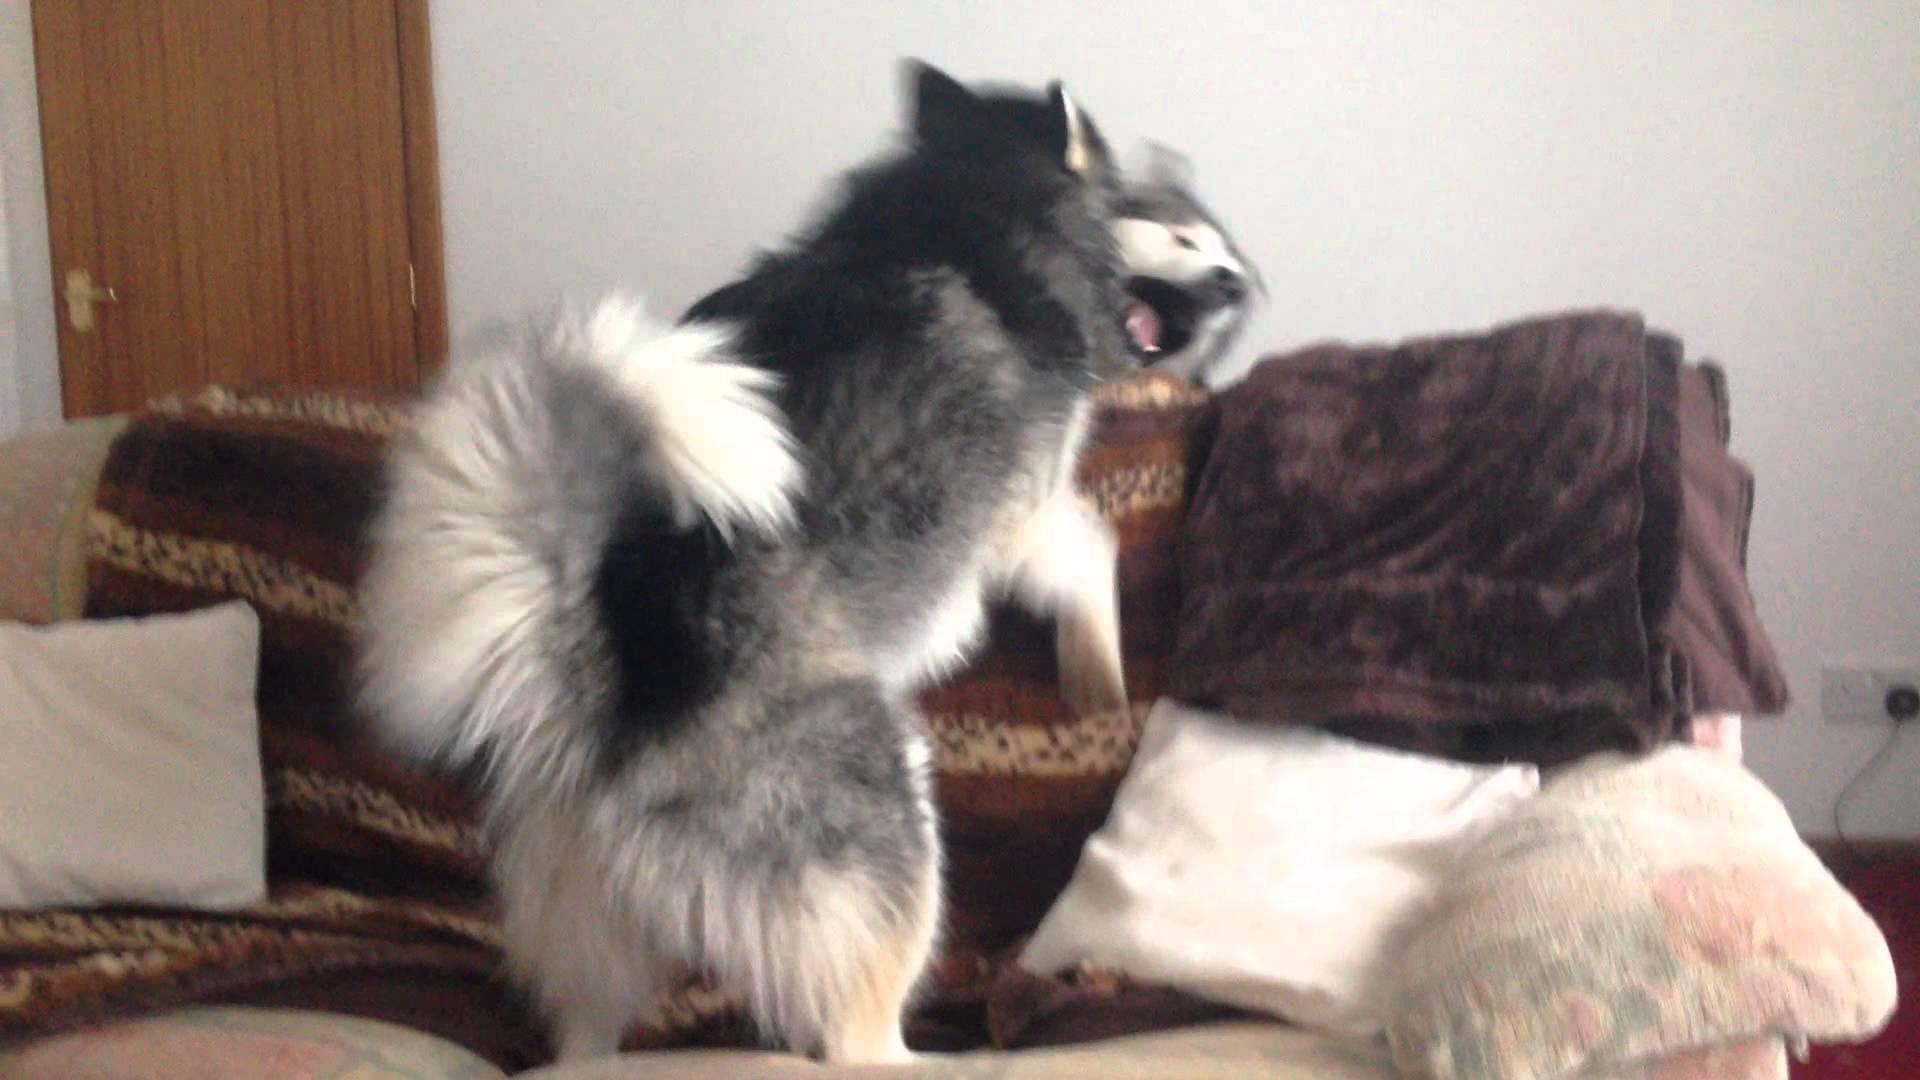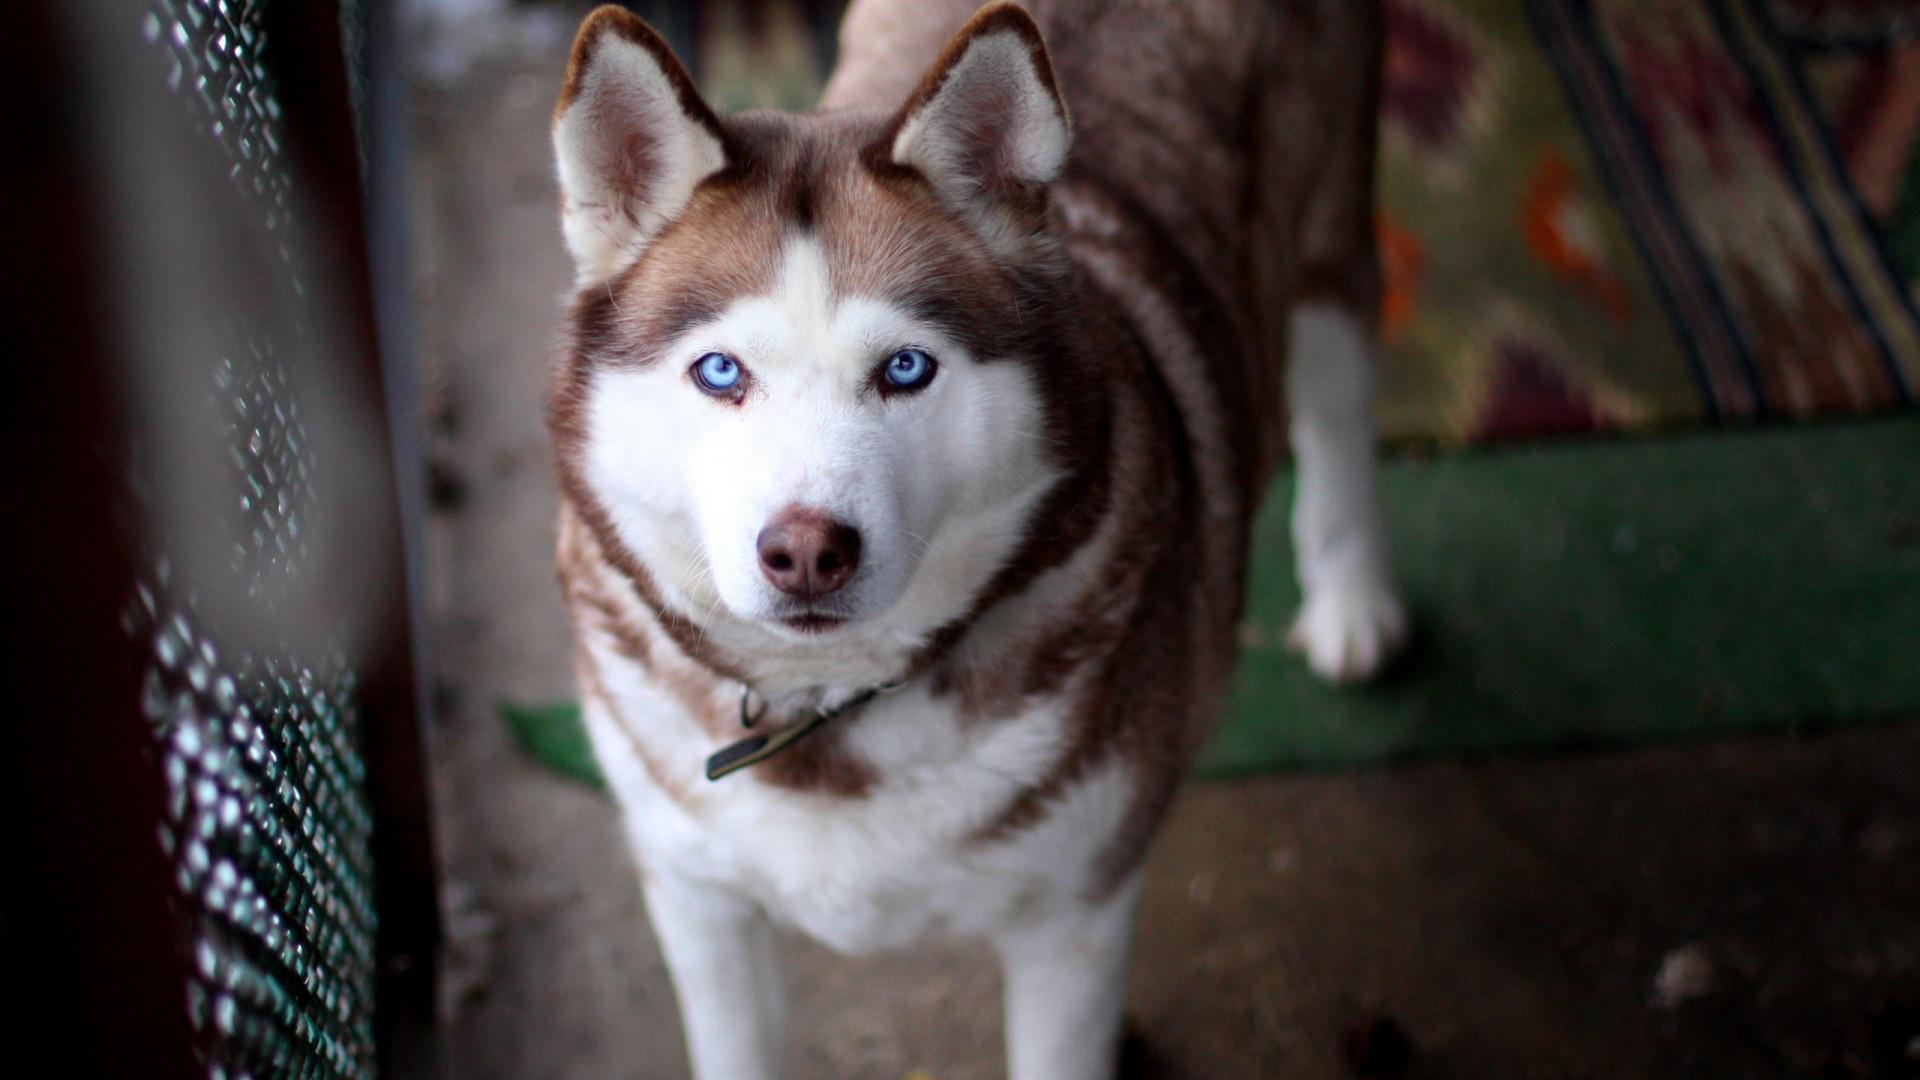The first image is the image on the left, the second image is the image on the right. Considering the images on both sides, is "Each image contains just one dog, all dogs are black-and-white husky types, and the dog on the right is reclining with extended front paws." valid? Answer yes or no. No. The first image is the image on the left, the second image is the image on the right. Evaluate the accuracy of this statement regarding the images: "The dog in the image on the right is indoors.". Is it true? Answer yes or no. Yes. 